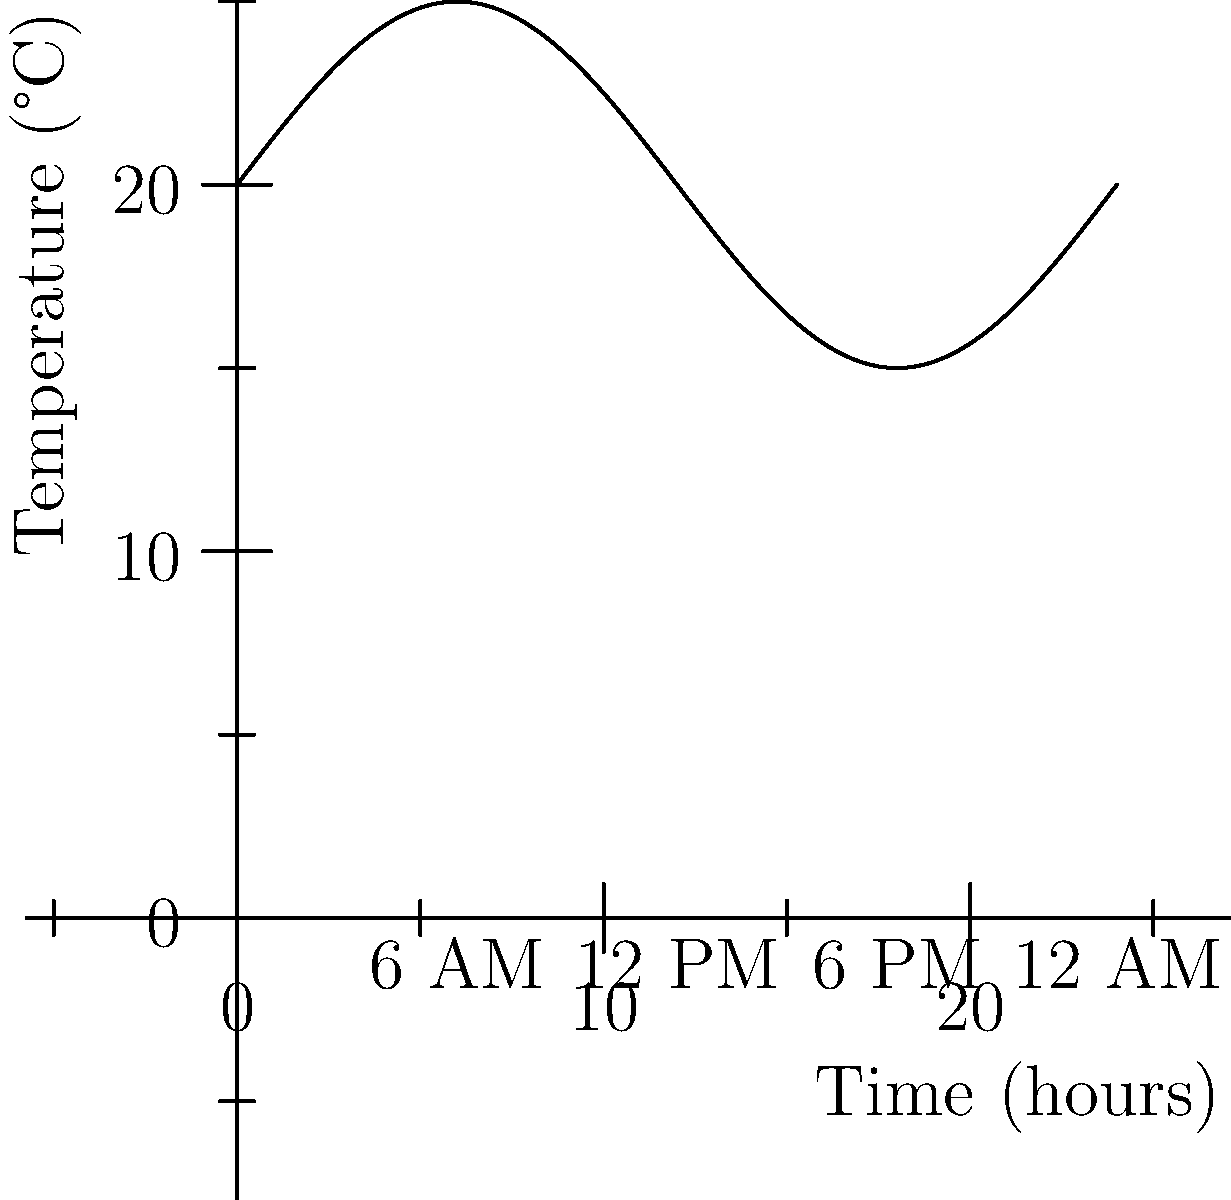Based on the temperature graph for the trip destination, at what time of day would it be most suitable to schedule outdoor activities for the students? To determine the best time for outdoor activities, we need to analyze the temperature changes throughout the day:

1. The graph shows a sinusoidal curve representing temperature fluctuations over 24 hours.
2. The temperature is lowest around 6 AM and highest around 3 PM.
3. For outdoor activities, we want to avoid the hottest part of the day to prevent heat exhaustion.
4. The most comfortable temperatures are typically in the morning or late afternoon.
5. From the graph, we can see that temperatures start rising after 6 AM and begin to decrease after 3 PM.
6. The period between 9 AM and 12 PM offers a good balance of daylight and moderate temperatures.
7. This time frame allows for activities to be completed before the peak heat of the day.

Therefore, scheduling outdoor activities in the morning, particularly between 9 AM and 12 PM, would be most suitable for the students.
Answer: 9 AM to 12 PM 